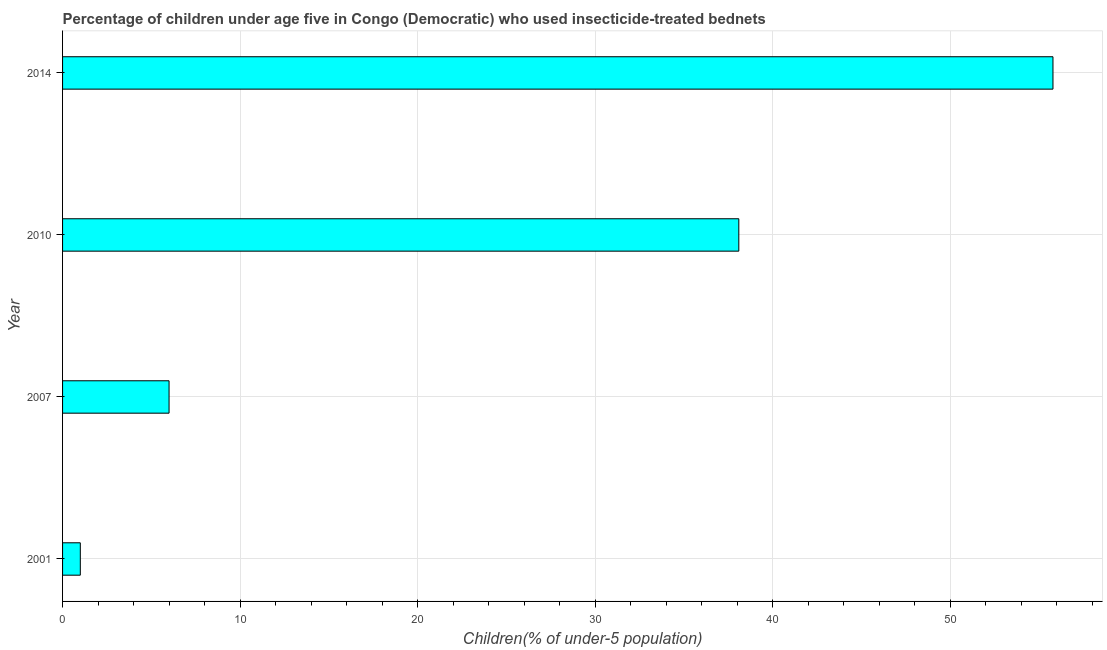Does the graph contain any zero values?
Keep it short and to the point. No. Does the graph contain grids?
Give a very brief answer. Yes. What is the title of the graph?
Your response must be concise. Percentage of children under age five in Congo (Democratic) who used insecticide-treated bednets. What is the label or title of the X-axis?
Offer a very short reply. Children(% of under-5 population). What is the label or title of the Y-axis?
Your answer should be very brief. Year. What is the percentage of children who use of insecticide-treated bed nets in 2014?
Provide a succinct answer. 55.8. Across all years, what is the maximum percentage of children who use of insecticide-treated bed nets?
Keep it short and to the point. 55.8. What is the sum of the percentage of children who use of insecticide-treated bed nets?
Provide a succinct answer. 100.9. What is the difference between the percentage of children who use of insecticide-treated bed nets in 2001 and 2014?
Your response must be concise. -54.8. What is the average percentage of children who use of insecticide-treated bed nets per year?
Offer a very short reply. 25.23. What is the median percentage of children who use of insecticide-treated bed nets?
Your answer should be compact. 22.05. In how many years, is the percentage of children who use of insecticide-treated bed nets greater than 50 %?
Provide a succinct answer. 1. What is the ratio of the percentage of children who use of insecticide-treated bed nets in 2001 to that in 2014?
Ensure brevity in your answer.  0.02. Is the percentage of children who use of insecticide-treated bed nets in 2007 less than that in 2010?
Make the answer very short. Yes. Is the sum of the percentage of children who use of insecticide-treated bed nets in 2001 and 2014 greater than the maximum percentage of children who use of insecticide-treated bed nets across all years?
Ensure brevity in your answer.  Yes. What is the difference between the highest and the lowest percentage of children who use of insecticide-treated bed nets?
Your answer should be compact. 54.8. In how many years, is the percentage of children who use of insecticide-treated bed nets greater than the average percentage of children who use of insecticide-treated bed nets taken over all years?
Give a very brief answer. 2. How many bars are there?
Provide a short and direct response. 4. How many years are there in the graph?
Offer a terse response. 4. What is the Children(% of under-5 population) in 2010?
Ensure brevity in your answer.  38.1. What is the Children(% of under-5 population) in 2014?
Keep it short and to the point. 55.8. What is the difference between the Children(% of under-5 population) in 2001 and 2007?
Ensure brevity in your answer.  -5. What is the difference between the Children(% of under-5 population) in 2001 and 2010?
Provide a succinct answer. -37.1. What is the difference between the Children(% of under-5 population) in 2001 and 2014?
Offer a terse response. -54.8. What is the difference between the Children(% of under-5 population) in 2007 and 2010?
Give a very brief answer. -32.1. What is the difference between the Children(% of under-5 population) in 2007 and 2014?
Offer a very short reply. -49.8. What is the difference between the Children(% of under-5 population) in 2010 and 2014?
Keep it short and to the point. -17.7. What is the ratio of the Children(% of under-5 population) in 2001 to that in 2007?
Provide a succinct answer. 0.17. What is the ratio of the Children(% of under-5 population) in 2001 to that in 2010?
Make the answer very short. 0.03. What is the ratio of the Children(% of under-5 population) in 2001 to that in 2014?
Offer a terse response. 0.02. What is the ratio of the Children(% of under-5 population) in 2007 to that in 2010?
Provide a succinct answer. 0.16. What is the ratio of the Children(% of under-5 population) in 2007 to that in 2014?
Offer a very short reply. 0.11. What is the ratio of the Children(% of under-5 population) in 2010 to that in 2014?
Offer a very short reply. 0.68. 